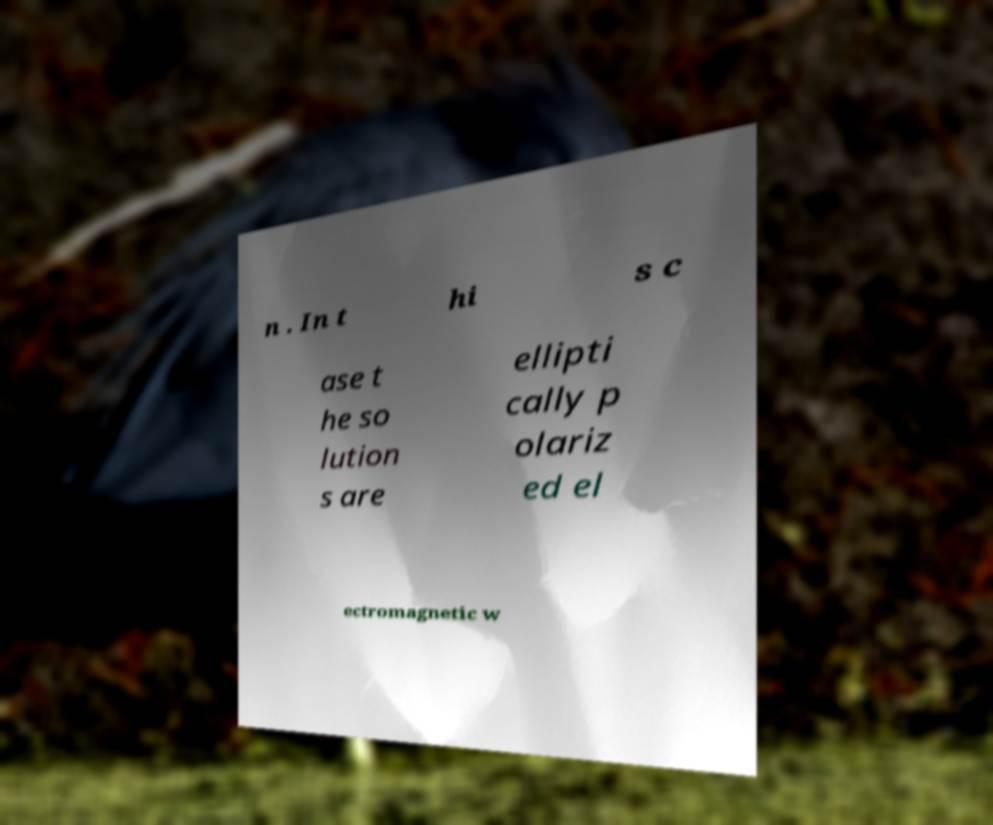For documentation purposes, I need the text within this image transcribed. Could you provide that? n . In t hi s c ase t he so lution s are ellipti cally p olariz ed el ectromagnetic w 